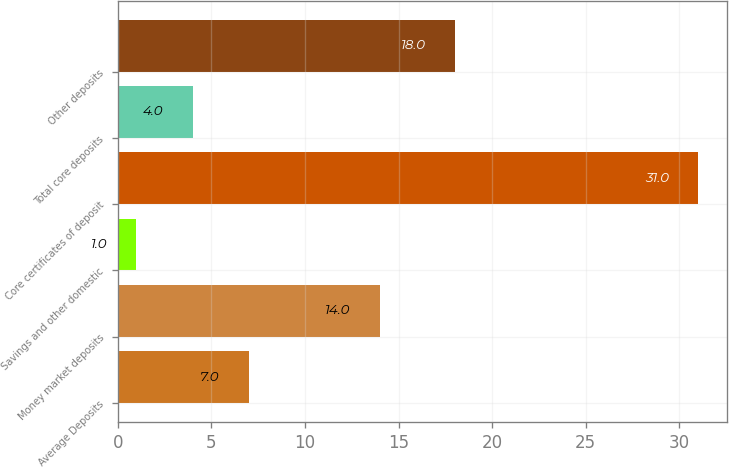Convert chart to OTSL. <chart><loc_0><loc_0><loc_500><loc_500><bar_chart><fcel>Average Deposits<fcel>Money market deposits<fcel>Savings and other domestic<fcel>Core certificates of deposit<fcel>Total core deposits<fcel>Other deposits<nl><fcel>7<fcel>14<fcel>1<fcel>31<fcel>4<fcel>18<nl></chart> 